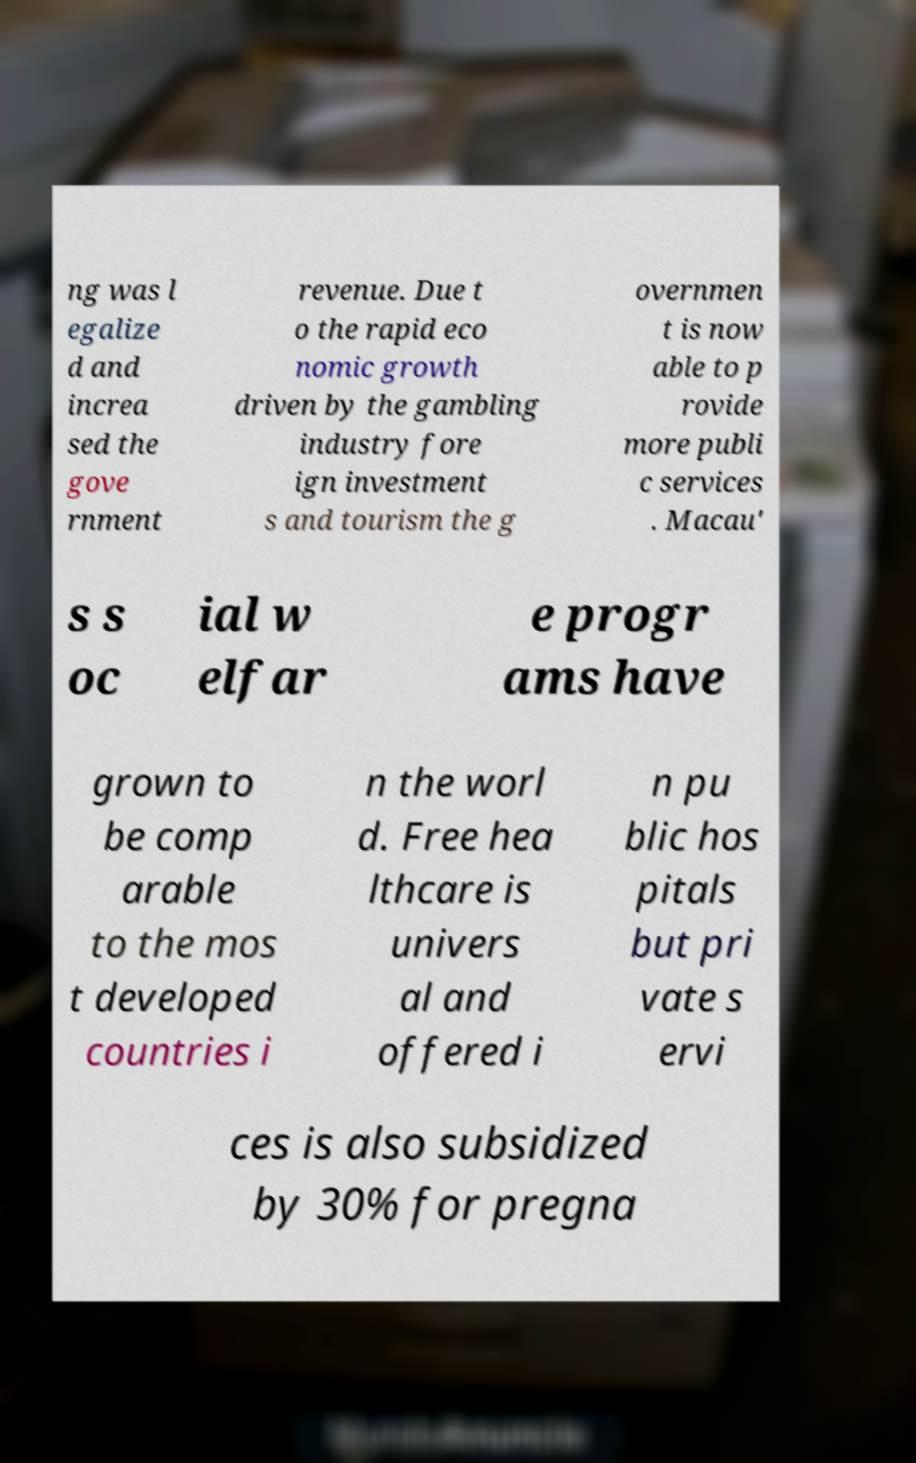Please identify and transcribe the text found in this image. ng was l egalize d and increa sed the gove rnment revenue. Due t o the rapid eco nomic growth driven by the gambling industry fore ign investment s and tourism the g overnmen t is now able to p rovide more publi c services . Macau' s s oc ial w elfar e progr ams have grown to be comp arable to the mos t developed countries i n the worl d. Free hea lthcare is univers al and offered i n pu blic hos pitals but pri vate s ervi ces is also subsidized by 30% for pregna 